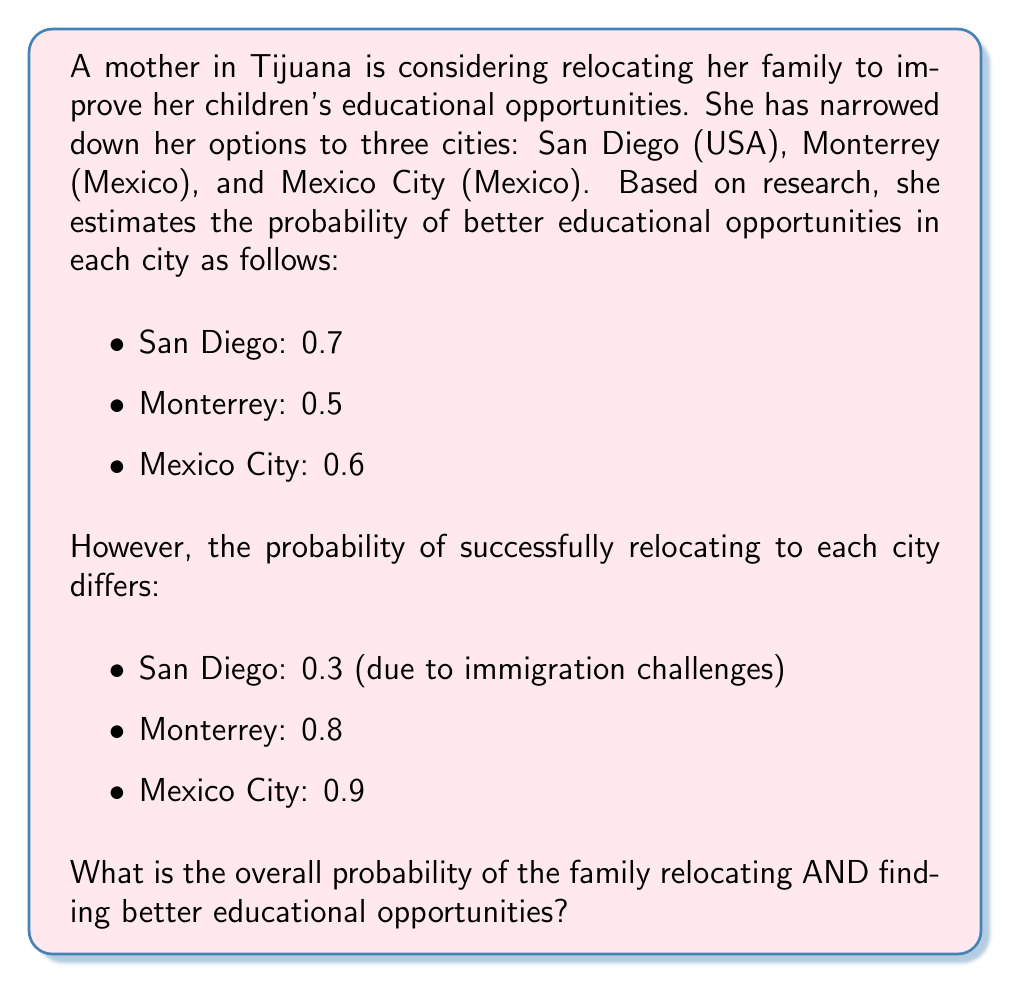What is the answer to this math problem? To solve this problem, we need to use the concept of total probability. We'll calculate the probability of relocating and finding better educational opportunities for each city, then sum these probabilities.

For each city, we need to multiply the probability of relocating by the probability of better educational opportunities:

1. San Diego:
   $P(\text{San Diego}) = 0.3 \times 0.7 = 0.21$

2. Monterrey:
   $P(\text{Monterrey}) = 0.8 \times 0.5 = 0.40$

3. Mexico City:
   $P(\text{Mexico City}) = 0.9 \times 0.6 = 0.54$

Now, we sum these probabilities to get the total probability:

$$P(\text{Relocating AND Better Education}) = P(\text{San Diego}) + P(\text{Monterrey}) + P(\text{Mexico City})$$
$$= 0.21 + 0.40 + 0.54 = 1.15$$

However, this sum exceeds 1, which is impossible for a probability. This is because the events are not mutually exclusive - the family could potentially relocate to more than one city over time.

To correct for this, we need to use the inclusion-exclusion principle. However, without additional information about the dependencies between these events, we cannot calculate the exact probability. 

In this case, we can provide a range for the probability:

Lower bound: The highest individual probability (Mexico City) = 0.54
Upper bound: The sum of all probabilities, capped at 1 = 1

Therefore, the overall probability of relocating AND finding better educational opportunities is between 0.54 and 1.
Answer: The overall probability of the family relocating AND finding better educational opportunities is between 0.54 and 1. 